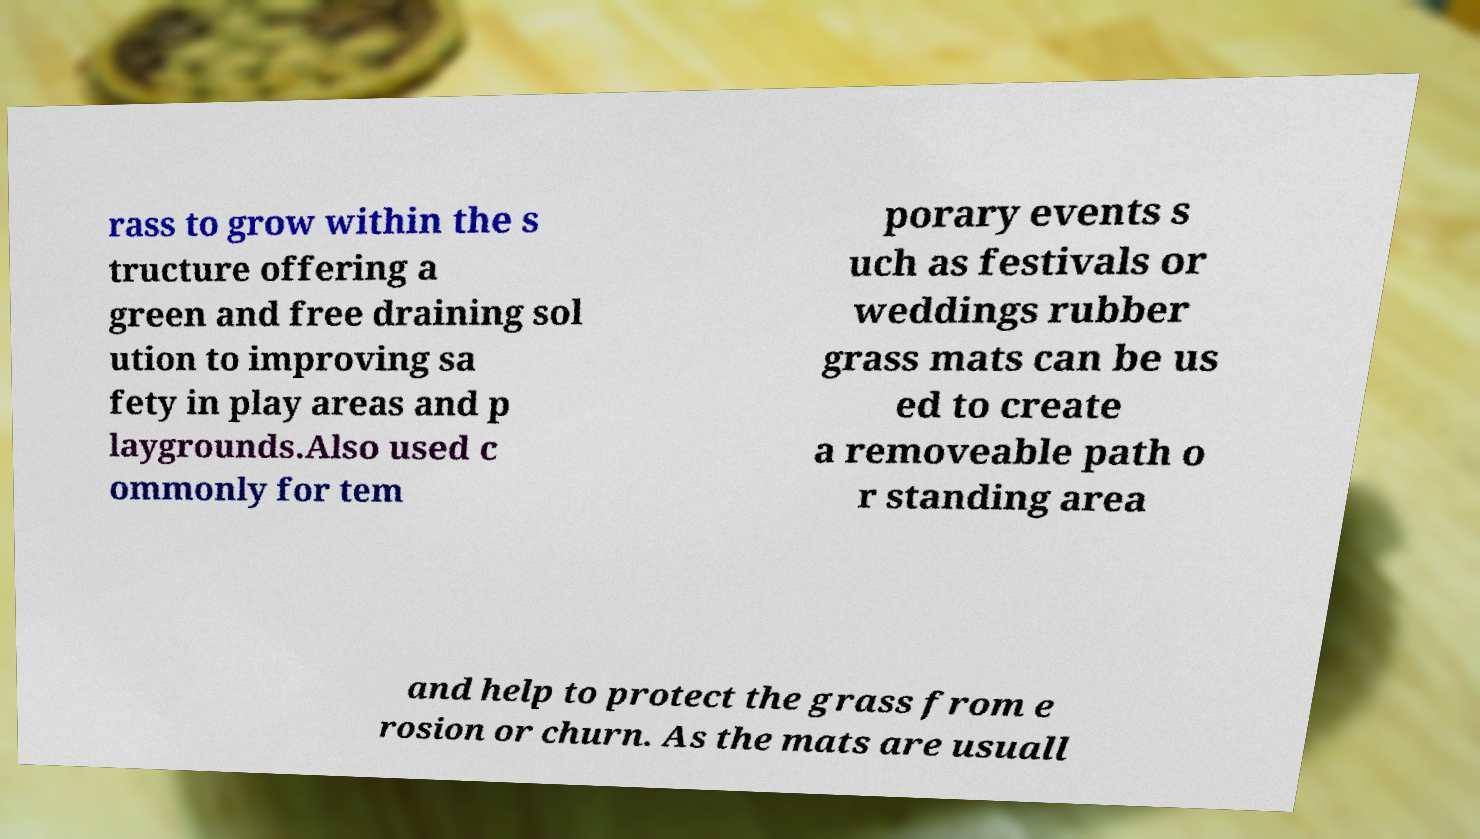I need the written content from this picture converted into text. Can you do that? rass to grow within the s tructure offering a green and free draining sol ution to improving sa fety in play areas and p laygrounds.Also used c ommonly for tem porary events s uch as festivals or weddings rubber grass mats can be us ed to create a removeable path o r standing area and help to protect the grass from e rosion or churn. As the mats are usuall 